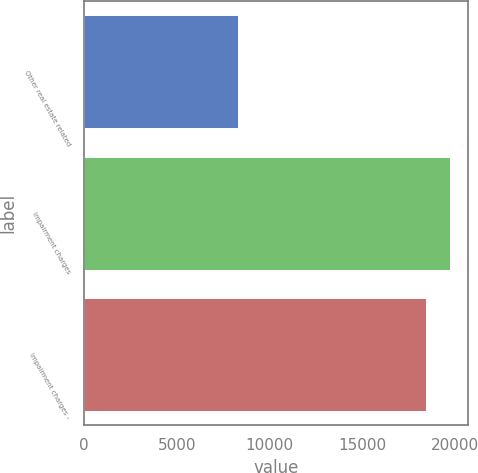Convert chart to OTSL. <chart><loc_0><loc_0><loc_500><loc_500><bar_chart><fcel>Other real estate related<fcel>Impairment charges<fcel>Impairment charges -<nl><fcel>8298<fcel>19729<fcel>18463<nl></chart> 